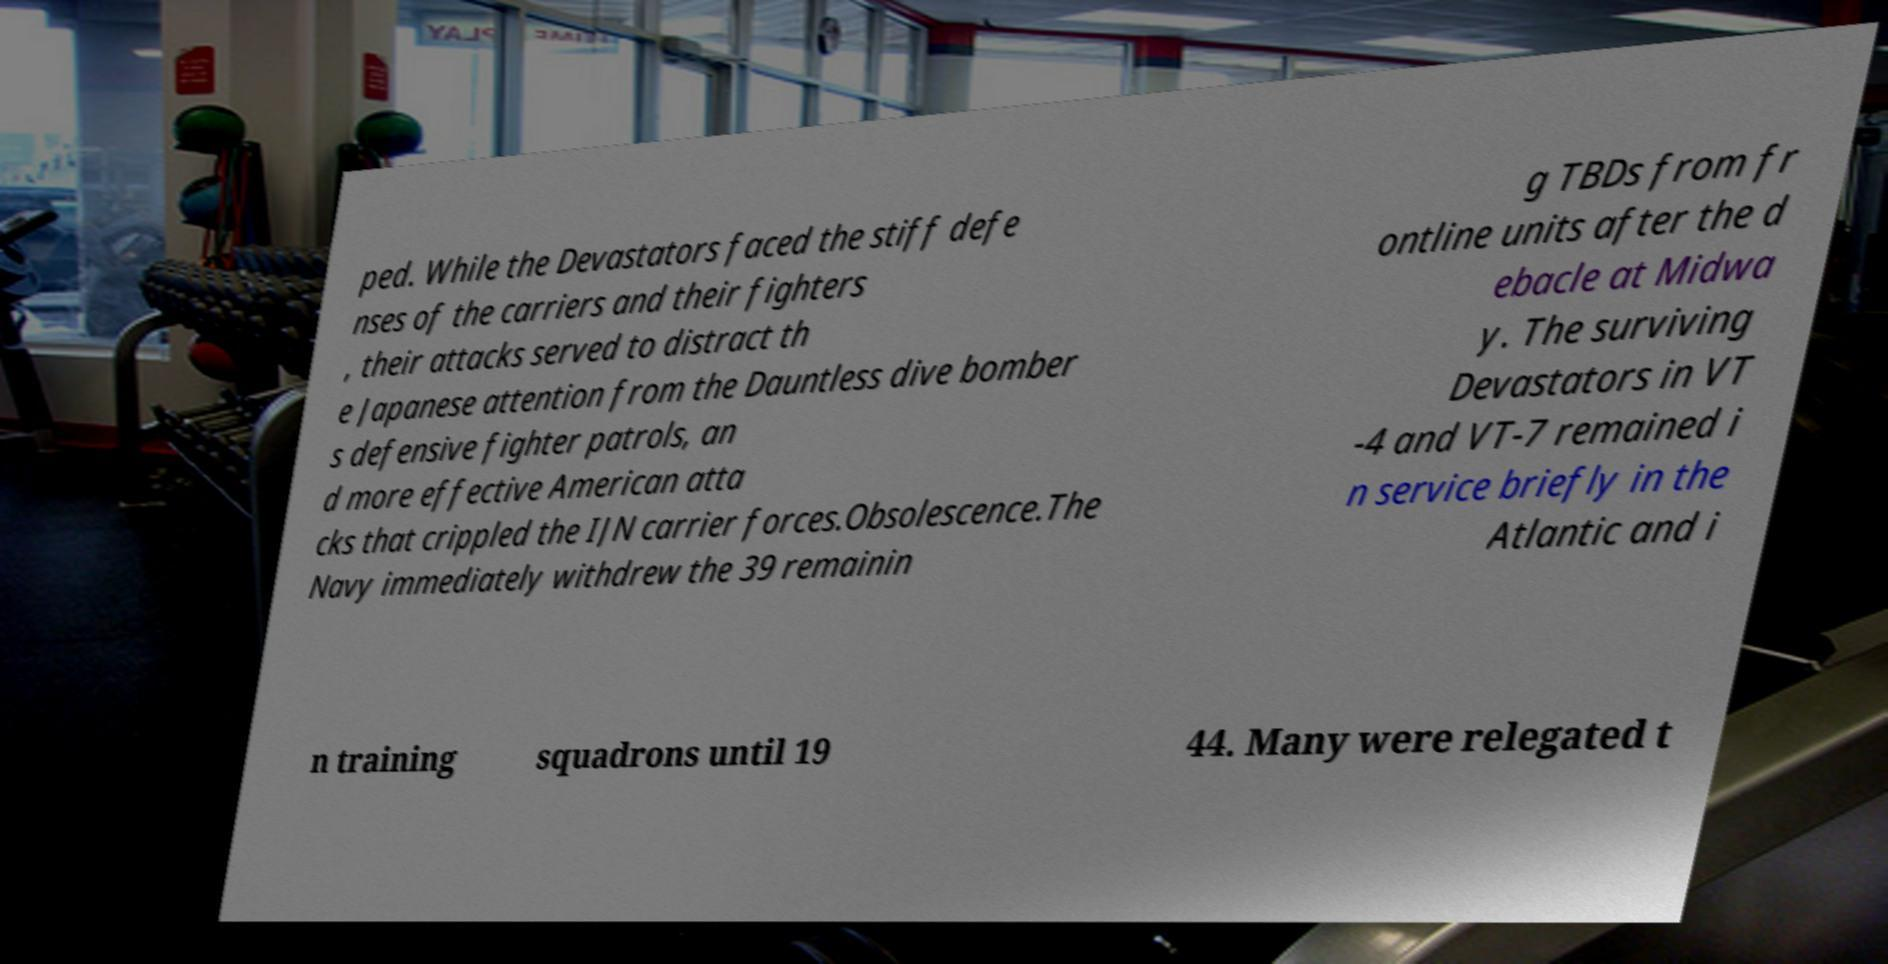Could you extract and type out the text from this image? ped. While the Devastators faced the stiff defe nses of the carriers and their fighters , their attacks served to distract th e Japanese attention from the Dauntless dive bomber s defensive fighter patrols, an d more effective American atta cks that crippled the IJN carrier forces.Obsolescence.The Navy immediately withdrew the 39 remainin g TBDs from fr ontline units after the d ebacle at Midwa y. The surviving Devastators in VT -4 and VT-7 remained i n service briefly in the Atlantic and i n training squadrons until 19 44. Many were relegated t 